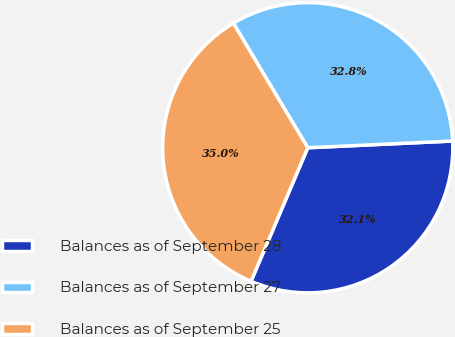Convert chart. <chart><loc_0><loc_0><loc_500><loc_500><pie_chart><fcel>Balances as of September 28<fcel>Balances as of September 27<fcel>Balances as of September 25<nl><fcel>32.13%<fcel>32.83%<fcel>35.04%<nl></chart> 